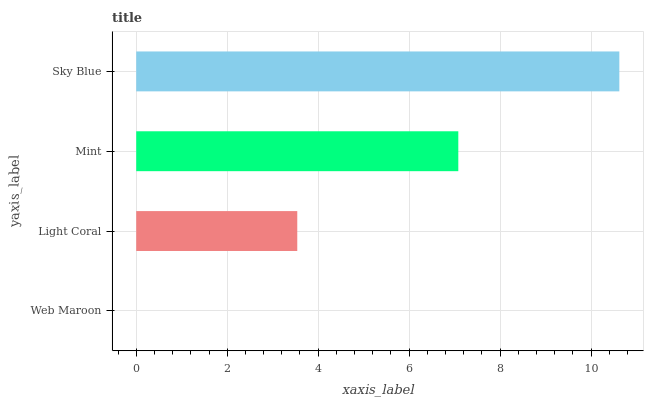Is Web Maroon the minimum?
Answer yes or no. Yes. Is Sky Blue the maximum?
Answer yes or no. Yes. Is Light Coral the minimum?
Answer yes or no. No. Is Light Coral the maximum?
Answer yes or no. No. Is Light Coral greater than Web Maroon?
Answer yes or no. Yes. Is Web Maroon less than Light Coral?
Answer yes or no. Yes. Is Web Maroon greater than Light Coral?
Answer yes or no. No. Is Light Coral less than Web Maroon?
Answer yes or no. No. Is Mint the high median?
Answer yes or no. Yes. Is Light Coral the low median?
Answer yes or no. Yes. Is Web Maroon the high median?
Answer yes or no. No. Is Mint the low median?
Answer yes or no. No. 